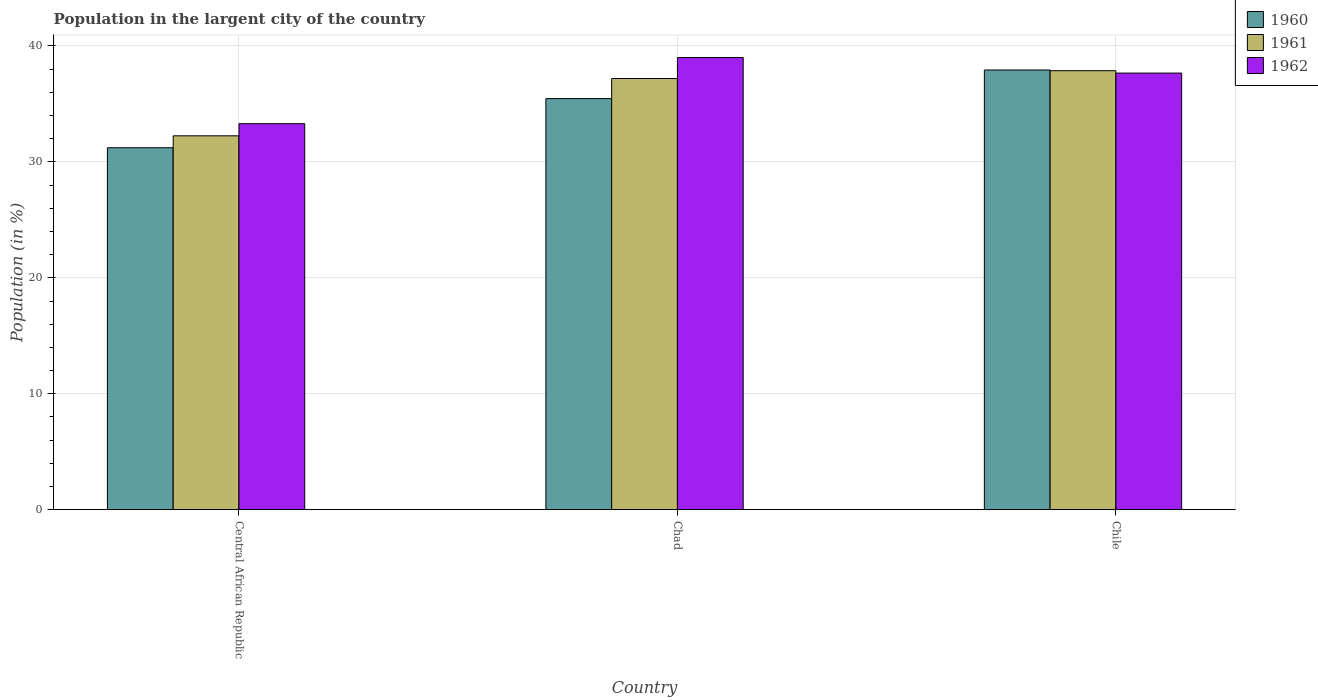Are the number of bars per tick equal to the number of legend labels?
Your answer should be very brief. Yes. Are the number of bars on each tick of the X-axis equal?
Make the answer very short. Yes. How many bars are there on the 2nd tick from the right?
Ensure brevity in your answer.  3. What is the label of the 1st group of bars from the left?
Your response must be concise. Central African Republic. In how many cases, is the number of bars for a given country not equal to the number of legend labels?
Offer a very short reply. 0. What is the percentage of population in the largent city in 1962 in Chad?
Keep it short and to the point. 39.01. Across all countries, what is the maximum percentage of population in the largent city in 1962?
Provide a succinct answer. 39.01. Across all countries, what is the minimum percentage of population in the largent city in 1962?
Ensure brevity in your answer.  33.29. In which country was the percentage of population in the largent city in 1962 maximum?
Provide a short and direct response. Chad. In which country was the percentage of population in the largent city in 1961 minimum?
Your response must be concise. Central African Republic. What is the total percentage of population in the largent city in 1960 in the graph?
Provide a succinct answer. 104.61. What is the difference between the percentage of population in the largent city in 1962 in Central African Republic and that in Chad?
Ensure brevity in your answer.  -5.71. What is the difference between the percentage of population in the largent city in 1961 in Chile and the percentage of population in the largent city in 1960 in Chad?
Your answer should be very brief. 2.41. What is the average percentage of population in the largent city in 1960 per country?
Keep it short and to the point. 34.87. What is the difference between the percentage of population in the largent city of/in 1962 and percentage of population in the largent city of/in 1960 in Chad?
Your response must be concise. 3.55. In how many countries, is the percentage of population in the largent city in 1960 greater than 16 %?
Provide a short and direct response. 3. What is the ratio of the percentage of population in the largent city in 1962 in Central African Republic to that in Chad?
Give a very brief answer. 0.85. Is the percentage of population in the largent city in 1962 in Chad less than that in Chile?
Provide a short and direct response. No. What is the difference between the highest and the second highest percentage of population in the largent city in 1960?
Make the answer very short. -2.47. What is the difference between the highest and the lowest percentage of population in the largent city in 1960?
Keep it short and to the point. 6.71. Is the sum of the percentage of population in the largent city in 1961 in Chad and Chile greater than the maximum percentage of population in the largent city in 1960 across all countries?
Provide a short and direct response. Yes. What does the 1st bar from the right in Chad represents?
Offer a very short reply. 1962. How many bars are there?
Offer a very short reply. 9. Does the graph contain any zero values?
Your response must be concise. No. Where does the legend appear in the graph?
Your answer should be compact. Top right. What is the title of the graph?
Your answer should be compact. Population in the largent city of the country. Does "2010" appear as one of the legend labels in the graph?
Your answer should be very brief. No. What is the label or title of the X-axis?
Your response must be concise. Country. What is the label or title of the Y-axis?
Offer a very short reply. Population (in %). What is the Population (in %) in 1960 in Central African Republic?
Your answer should be very brief. 31.22. What is the Population (in %) in 1961 in Central African Republic?
Your answer should be very brief. 32.25. What is the Population (in %) in 1962 in Central African Republic?
Offer a very short reply. 33.29. What is the Population (in %) of 1960 in Chad?
Keep it short and to the point. 35.46. What is the Population (in %) in 1961 in Chad?
Your response must be concise. 37.19. What is the Population (in %) of 1962 in Chad?
Your answer should be very brief. 39.01. What is the Population (in %) of 1960 in Chile?
Ensure brevity in your answer.  37.93. What is the Population (in %) in 1961 in Chile?
Provide a succinct answer. 37.87. What is the Population (in %) of 1962 in Chile?
Keep it short and to the point. 37.66. Across all countries, what is the maximum Population (in %) in 1960?
Offer a terse response. 37.93. Across all countries, what is the maximum Population (in %) in 1961?
Provide a succinct answer. 37.87. Across all countries, what is the maximum Population (in %) of 1962?
Provide a succinct answer. 39.01. Across all countries, what is the minimum Population (in %) in 1960?
Your answer should be compact. 31.22. Across all countries, what is the minimum Population (in %) of 1961?
Provide a succinct answer. 32.25. Across all countries, what is the minimum Population (in %) in 1962?
Ensure brevity in your answer.  33.29. What is the total Population (in %) in 1960 in the graph?
Provide a short and direct response. 104.61. What is the total Population (in %) of 1961 in the graph?
Provide a short and direct response. 107.31. What is the total Population (in %) of 1962 in the graph?
Keep it short and to the point. 109.96. What is the difference between the Population (in %) in 1960 in Central African Republic and that in Chad?
Keep it short and to the point. -4.24. What is the difference between the Population (in %) of 1961 in Central African Republic and that in Chad?
Your response must be concise. -4.94. What is the difference between the Population (in %) of 1962 in Central African Republic and that in Chad?
Give a very brief answer. -5.71. What is the difference between the Population (in %) in 1960 in Central African Republic and that in Chile?
Provide a succinct answer. -6.71. What is the difference between the Population (in %) of 1961 in Central African Republic and that in Chile?
Your answer should be compact. -5.62. What is the difference between the Population (in %) in 1962 in Central African Republic and that in Chile?
Offer a very short reply. -4.36. What is the difference between the Population (in %) of 1960 in Chad and that in Chile?
Offer a terse response. -2.47. What is the difference between the Population (in %) of 1961 in Chad and that in Chile?
Your answer should be very brief. -0.68. What is the difference between the Population (in %) of 1962 in Chad and that in Chile?
Give a very brief answer. 1.35. What is the difference between the Population (in %) in 1960 in Central African Republic and the Population (in %) in 1961 in Chad?
Ensure brevity in your answer.  -5.97. What is the difference between the Population (in %) in 1960 in Central African Republic and the Population (in %) in 1962 in Chad?
Provide a succinct answer. -7.78. What is the difference between the Population (in %) in 1961 in Central African Republic and the Population (in %) in 1962 in Chad?
Your answer should be very brief. -6.76. What is the difference between the Population (in %) in 1960 in Central African Republic and the Population (in %) in 1961 in Chile?
Provide a short and direct response. -6.65. What is the difference between the Population (in %) in 1960 in Central African Republic and the Population (in %) in 1962 in Chile?
Offer a terse response. -6.44. What is the difference between the Population (in %) of 1961 in Central African Republic and the Population (in %) of 1962 in Chile?
Offer a very short reply. -5.41. What is the difference between the Population (in %) in 1960 in Chad and the Population (in %) in 1961 in Chile?
Offer a very short reply. -2.41. What is the difference between the Population (in %) of 1960 in Chad and the Population (in %) of 1962 in Chile?
Ensure brevity in your answer.  -2.2. What is the difference between the Population (in %) of 1961 in Chad and the Population (in %) of 1962 in Chile?
Keep it short and to the point. -0.47. What is the average Population (in %) of 1960 per country?
Give a very brief answer. 34.87. What is the average Population (in %) of 1961 per country?
Provide a succinct answer. 35.77. What is the average Population (in %) in 1962 per country?
Offer a very short reply. 36.65. What is the difference between the Population (in %) in 1960 and Population (in %) in 1961 in Central African Republic?
Keep it short and to the point. -1.03. What is the difference between the Population (in %) in 1960 and Population (in %) in 1962 in Central African Republic?
Offer a very short reply. -2.07. What is the difference between the Population (in %) of 1961 and Population (in %) of 1962 in Central African Republic?
Your response must be concise. -1.05. What is the difference between the Population (in %) in 1960 and Population (in %) in 1961 in Chad?
Make the answer very short. -1.73. What is the difference between the Population (in %) in 1960 and Population (in %) in 1962 in Chad?
Offer a very short reply. -3.55. What is the difference between the Population (in %) in 1961 and Population (in %) in 1962 in Chad?
Your answer should be compact. -1.81. What is the difference between the Population (in %) of 1960 and Population (in %) of 1961 in Chile?
Give a very brief answer. 0.06. What is the difference between the Population (in %) of 1960 and Population (in %) of 1962 in Chile?
Keep it short and to the point. 0.27. What is the difference between the Population (in %) in 1961 and Population (in %) in 1962 in Chile?
Your response must be concise. 0.21. What is the ratio of the Population (in %) of 1960 in Central African Republic to that in Chad?
Your answer should be compact. 0.88. What is the ratio of the Population (in %) in 1961 in Central African Republic to that in Chad?
Provide a succinct answer. 0.87. What is the ratio of the Population (in %) of 1962 in Central African Republic to that in Chad?
Make the answer very short. 0.85. What is the ratio of the Population (in %) in 1960 in Central African Republic to that in Chile?
Give a very brief answer. 0.82. What is the ratio of the Population (in %) in 1961 in Central African Republic to that in Chile?
Provide a short and direct response. 0.85. What is the ratio of the Population (in %) in 1962 in Central African Republic to that in Chile?
Offer a very short reply. 0.88. What is the ratio of the Population (in %) in 1960 in Chad to that in Chile?
Your response must be concise. 0.93. What is the ratio of the Population (in %) of 1961 in Chad to that in Chile?
Make the answer very short. 0.98. What is the ratio of the Population (in %) of 1962 in Chad to that in Chile?
Ensure brevity in your answer.  1.04. What is the difference between the highest and the second highest Population (in %) in 1960?
Keep it short and to the point. 2.47. What is the difference between the highest and the second highest Population (in %) of 1961?
Offer a very short reply. 0.68. What is the difference between the highest and the second highest Population (in %) in 1962?
Give a very brief answer. 1.35. What is the difference between the highest and the lowest Population (in %) of 1960?
Give a very brief answer. 6.71. What is the difference between the highest and the lowest Population (in %) in 1961?
Ensure brevity in your answer.  5.62. What is the difference between the highest and the lowest Population (in %) in 1962?
Provide a short and direct response. 5.71. 